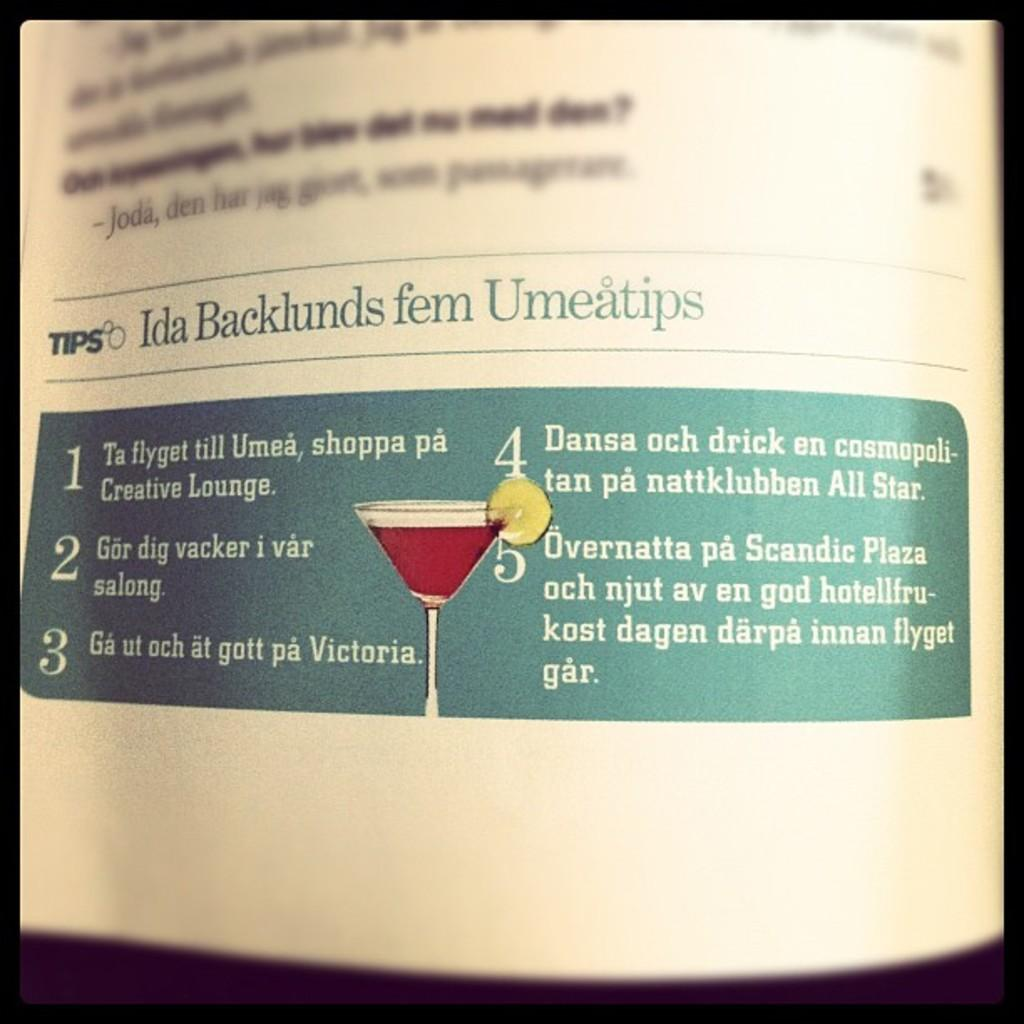<image>
Create a compact narrative representing the image presented. Ida Backlunds fem Umeatips banner on a magazine. 